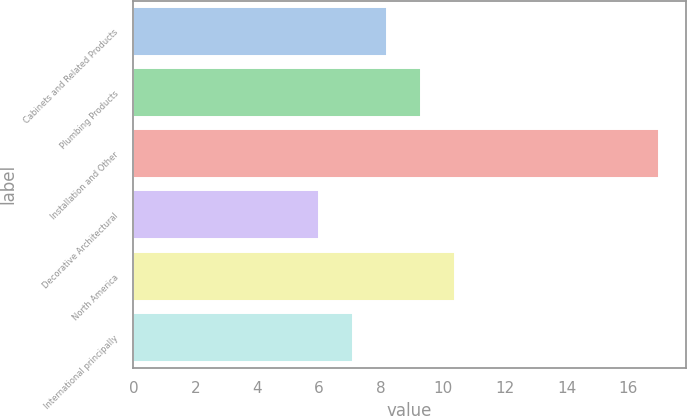<chart> <loc_0><loc_0><loc_500><loc_500><bar_chart><fcel>Cabinets and Related Products<fcel>Plumbing Products<fcel>Installation and Other<fcel>Decorative Architectural<fcel>North America<fcel>International principally<nl><fcel>8.2<fcel>9.3<fcel>17<fcel>6<fcel>10.4<fcel>7.1<nl></chart> 